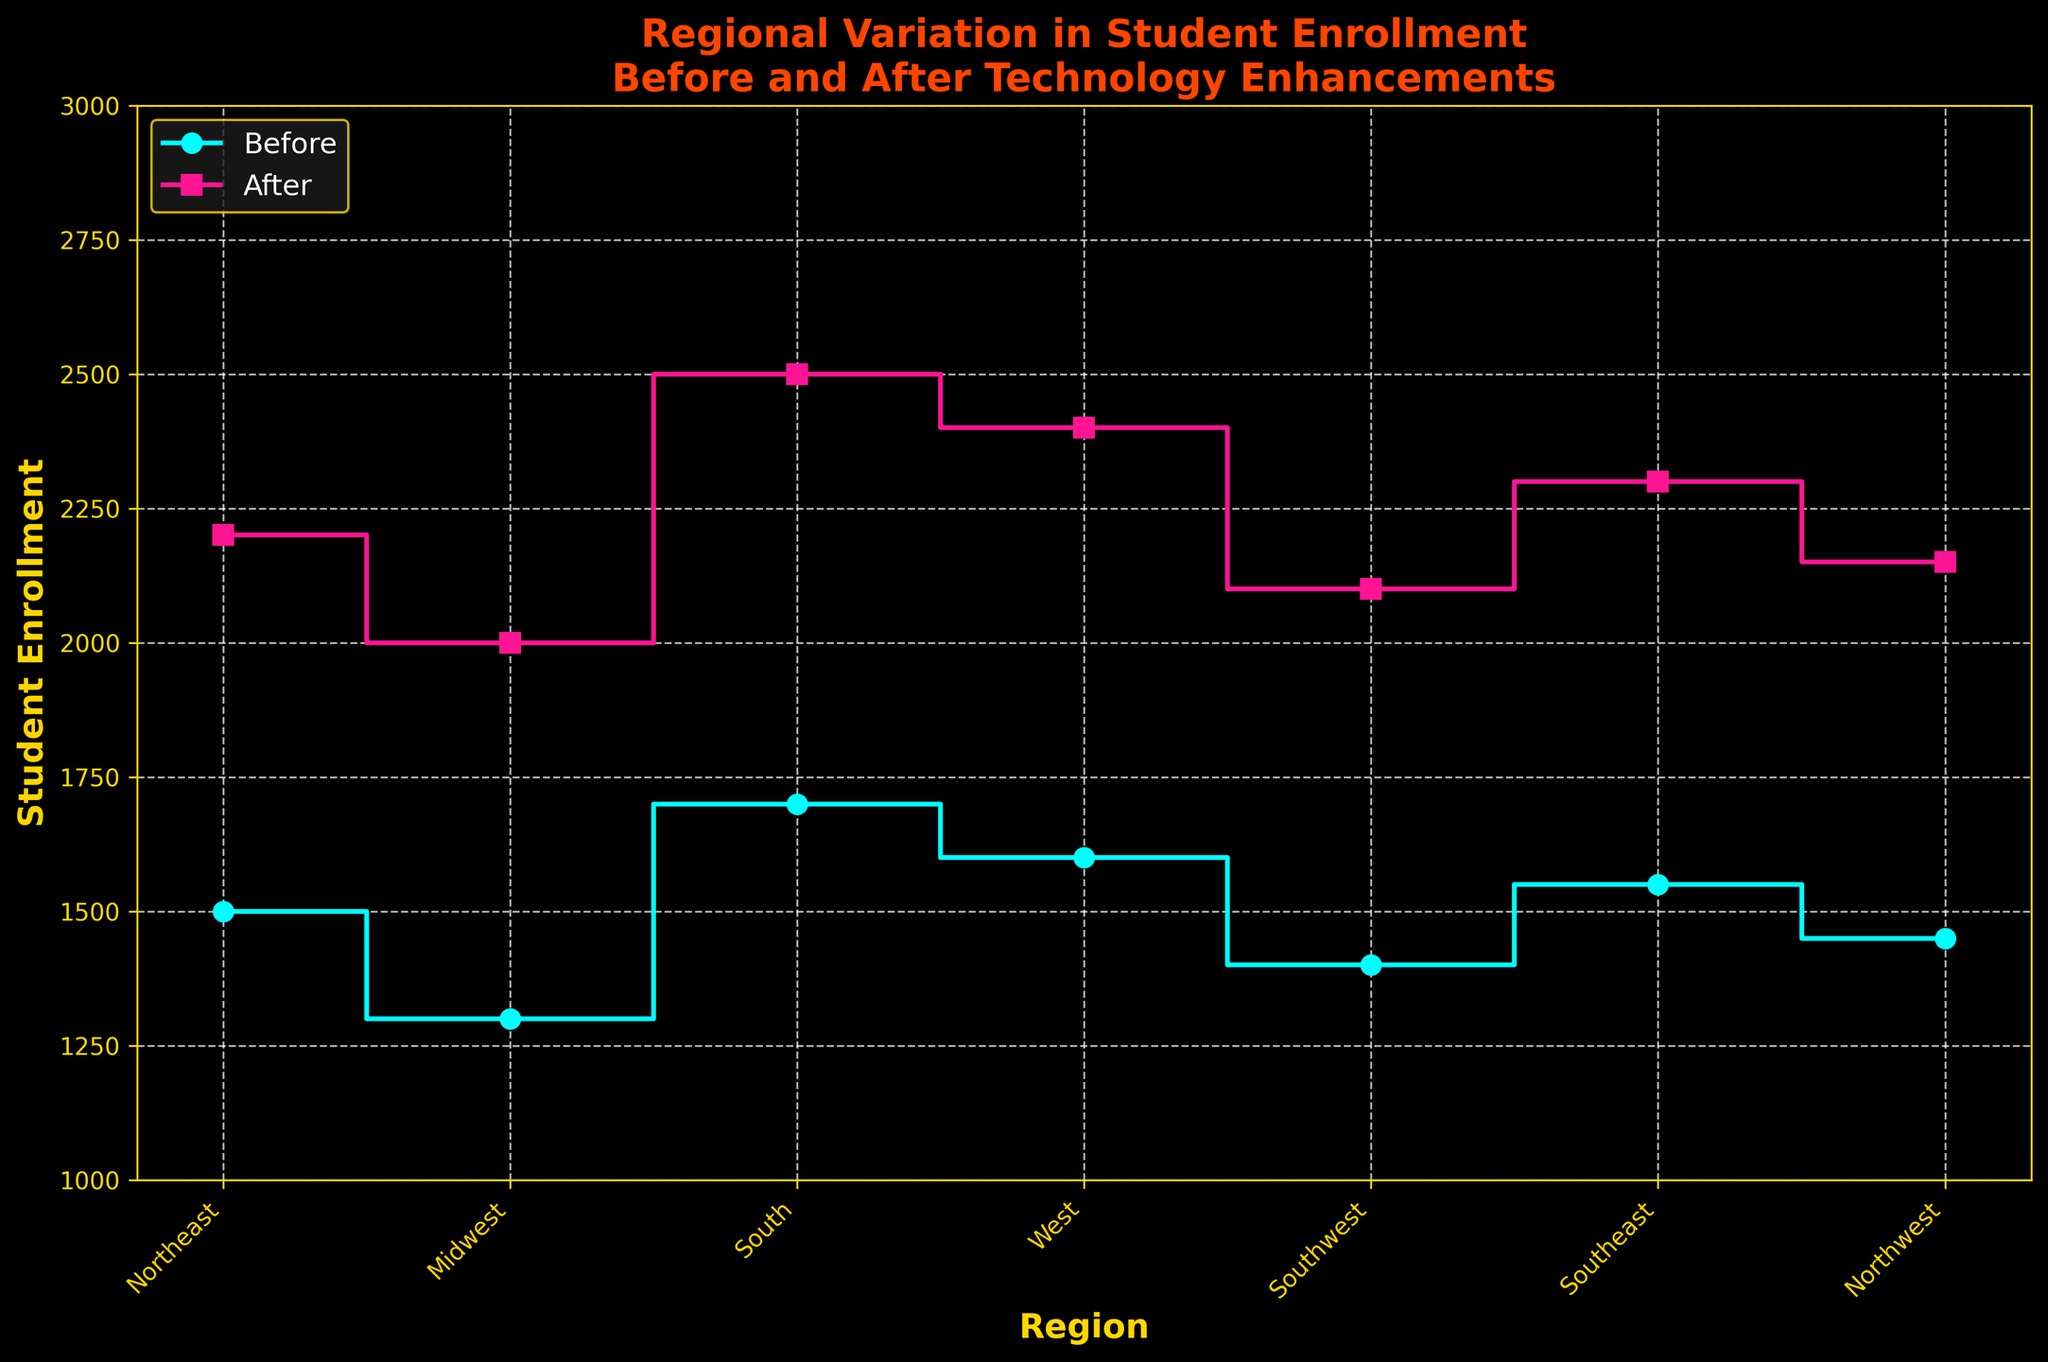What's the title of the figure? The title of a figure is usually found at the top, and in this case, it reads as "Regional Variation in Student Enrollment Before and After Technology Enhancements".
Answer: Regional Variation in Student Enrollment Before and After Technology Enhancements Which region has the highest student enrollment after technology enhancements? By looking at the 'After Technology Enhancements' line, the South region has the highest student enrollment which is depicted at 2500 students.
Answer: South How much did student enrollment increase in the Southwest region after technology enhancements? In the Southwest region, the enrollment increased from 1400 to 2100 after the enhancements. By computing the difference: 2100 - 1400, we get the answer.
Answer: 700 Which region has the smallest difference in enrollment before and after technology enhancements? To determine this, we calculate the difference for each region and compare. The smallest difference found is in the Southeast region with an increase from 1550 to 2300, which is 2300 - 1550 = 750.
Answer: Southeast What color represents the student enrollment after technology enhancements? By examining the legend, the color representing 'After' is pink.
Answer: Pink How many regions are depicted in the figure? Counting the different regions listed on the x-axis, we find there are 7 regions.
Answer: 7 What's the combined enrollment of the Northeast and Midwest regions before technology enhancements? Adding the student enrollments for the Northeast (1500) and Midwest (1300) regions gives: 1500 + 1300 = 2800.
Answer: 2800 Is there any region where the student enrollment remained the same before and after technology enhancements? Observing the plot, each region shows an increase in student enrollment after the technology enhancements, confirming no region stayed the same.
Answer: No Which region shows the smallest student enrollment after technology enhancements? By examining the 'After' line, the Midwest region shows the smallest student enrollment after the enhancements at 2000 students.
Answer: Midwest 